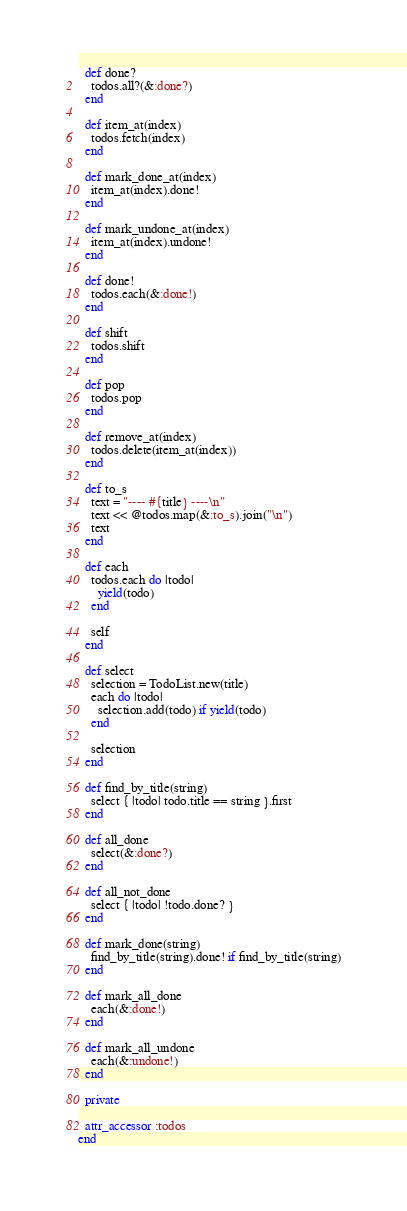<code> <loc_0><loc_0><loc_500><loc_500><_Ruby_>  def done?
    todos.all?(&:done?)
  end

  def item_at(index)
    todos.fetch(index)
  end

  def mark_done_at(index)
    item_at(index).done!
  end

  def mark_undone_at(index)
    item_at(index).undone!
  end

  def done!
    todos.each(&:done!)
  end

  def shift
    todos.shift
  end

  def pop
    todos.pop
  end

  def remove_at(index)
    todos.delete(item_at(index))
  end

  def to_s
    text = "---- #{title} ----\n"
    text << @todos.map(&:to_s).join("\n")
    text
  end

  def each
    todos.each do |todo|
      yield(todo)
    end

    self
  end

  def select
    selection = TodoList.new(title)
    each do |todo|
      selection.add(todo) if yield(todo)
    end

    selection
  end

  def find_by_title(string)
    select { |todo| todo.title == string }.first
  end

  def all_done
    select(&:done?)
  end

  def all_not_done
    select { |todo| !todo.done? }
  end

  def mark_done(string)
    find_by_title(string).done! if find_by_title(string)
  end

  def mark_all_done
    each(&:done!)
  end

  def mark_all_undone
    each(&:undone!)
  end

  private

  attr_accessor :todos
end
</code> 